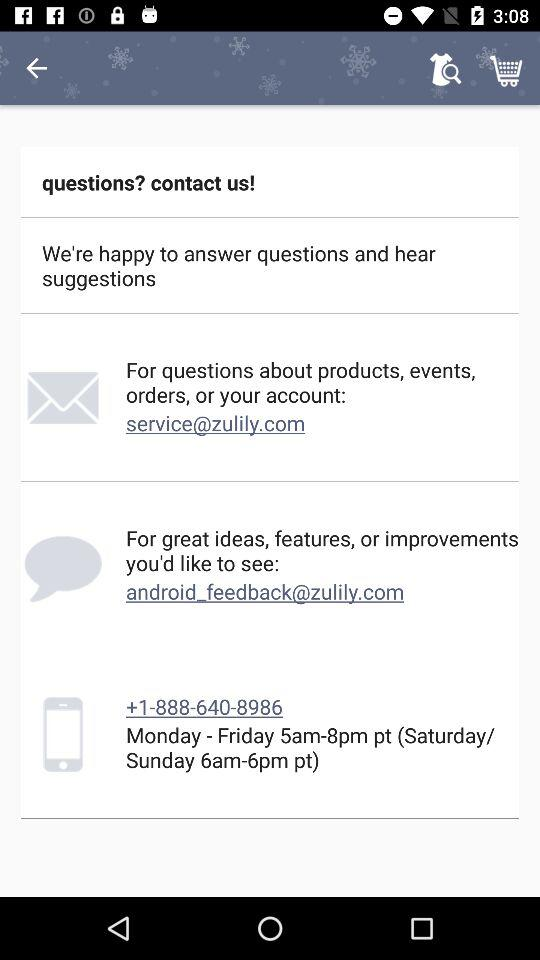How many contact options are there?
Answer the question using a single word or phrase. 3 